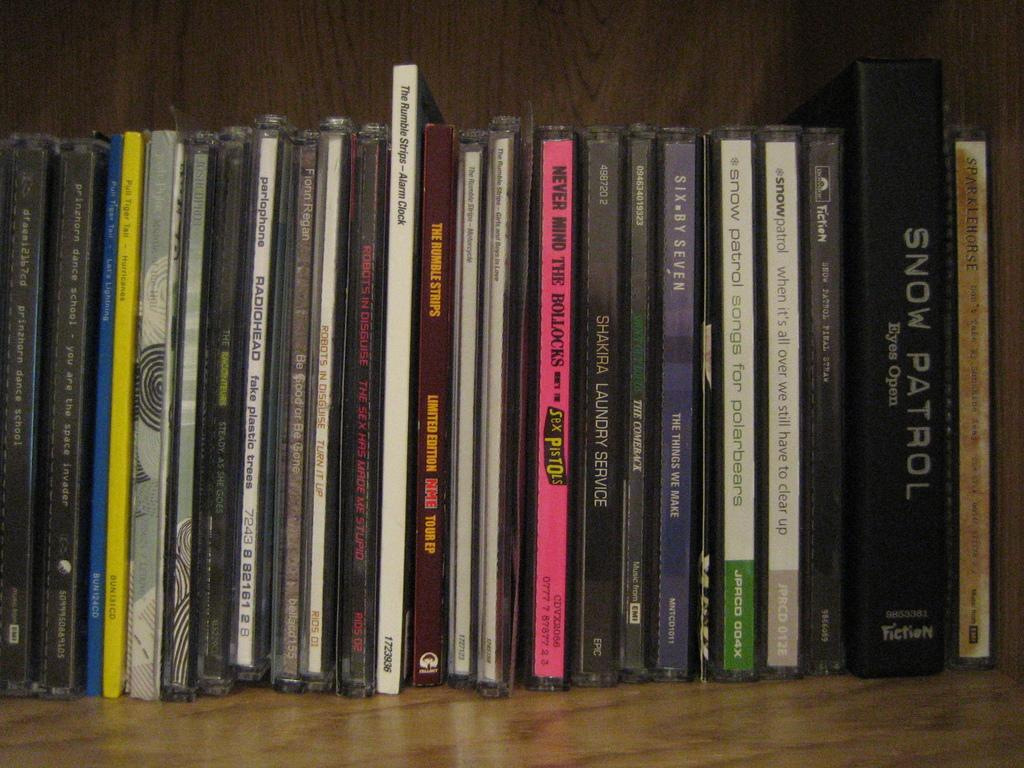<image>
Relay a brief, clear account of the picture shown. Books on a bookshelf with one in the center that is pink and titled Never Mind The Bollocks. 